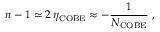<formula> <loc_0><loc_0><loc_500><loc_500>n - 1 \simeq 2 \, \eta _ { C O B E } \approx - \frac { 1 } { N _ { C O B E } } \, ,</formula> 